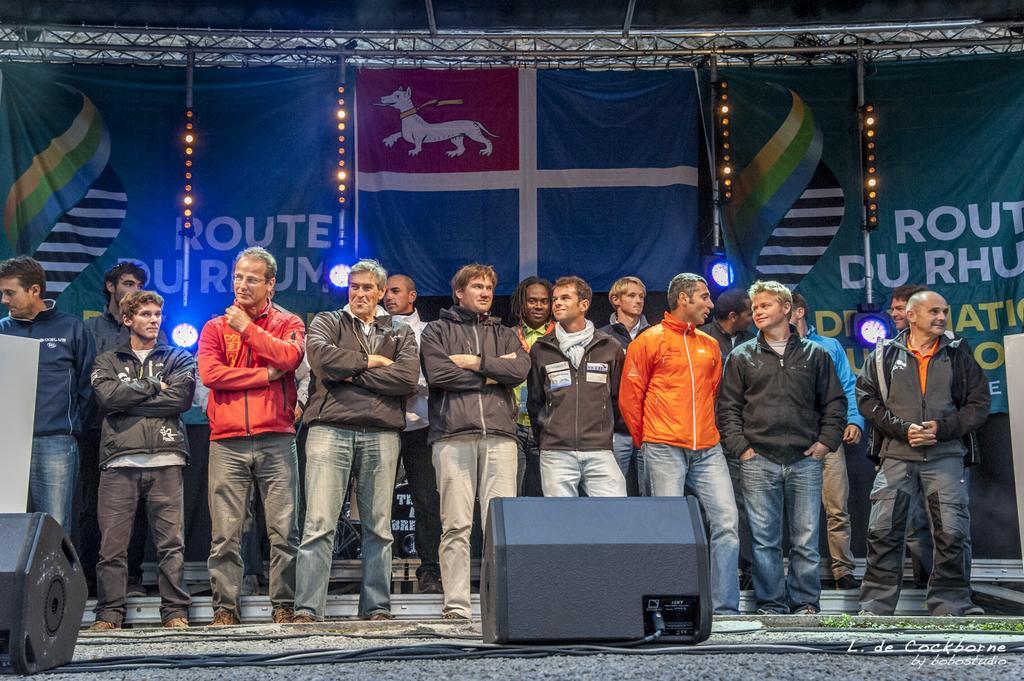Please provide a concise description of this image. In this image we can see group of persons wearing jackets standing on the stage, in the foreground of the image there are some sound boxes and in the background of the image there are some rods, lights and green color sheet. 